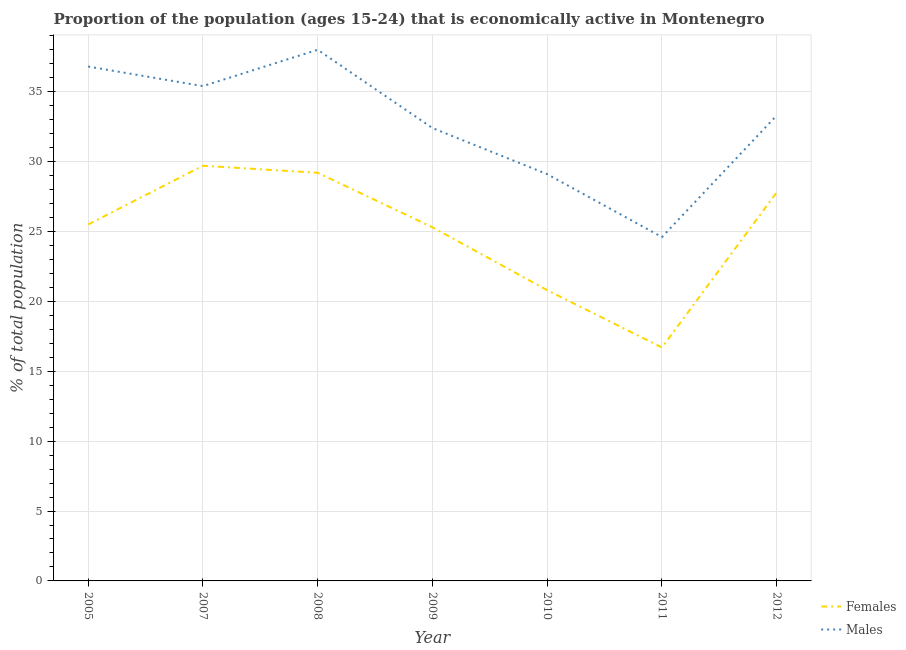How many different coloured lines are there?
Your response must be concise. 2. What is the percentage of economically active male population in 2010?
Ensure brevity in your answer.  29.1. Across all years, what is the minimum percentage of economically active male population?
Provide a short and direct response. 24.6. In which year was the percentage of economically active female population minimum?
Provide a succinct answer. 2011. What is the total percentage of economically active female population in the graph?
Your response must be concise. 175. What is the difference between the percentage of economically active male population in 2010 and that in 2012?
Keep it short and to the point. -4.2. What is the difference between the percentage of economically active female population in 2009 and the percentage of economically active male population in 2010?
Make the answer very short. -3.8. In the year 2010, what is the difference between the percentage of economically active female population and percentage of economically active male population?
Give a very brief answer. -8.3. In how many years, is the percentage of economically active male population greater than 14 %?
Give a very brief answer. 7. What is the ratio of the percentage of economically active female population in 2009 to that in 2011?
Make the answer very short. 1.51. Is the percentage of economically active male population in 2005 less than that in 2007?
Make the answer very short. No. Is the difference between the percentage of economically active female population in 2005 and 2008 greater than the difference between the percentage of economically active male population in 2005 and 2008?
Your answer should be very brief. No. What is the difference between the highest and the second highest percentage of economically active female population?
Make the answer very short. 0.5. What is the difference between the highest and the lowest percentage of economically active female population?
Provide a succinct answer. 13. In how many years, is the percentage of economically active female population greater than the average percentage of economically active female population taken over all years?
Keep it short and to the point. 5. How many years are there in the graph?
Offer a terse response. 7. Does the graph contain any zero values?
Make the answer very short. No. Does the graph contain grids?
Ensure brevity in your answer.  Yes. Where does the legend appear in the graph?
Ensure brevity in your answer.  Bottom right. What is the title of the graph?
Make the answer very short. Proportion of the population (ages 15-24) that is economically active in Montenegro. Does "Young" appear as one of the legend labels in the graph?
Keep it short and to the point. No. What is the label or title of the Y-axis?
Make the answer very short. % of total population. What is the % of total population in Females in 2005?
Provide a succinct answer. 25.5. What is the % of total population of Males in 2005?
Make the answer very short. 36.8. What is the % of total population of Females in 2007?
Ensure brevity in your answer.  29.7. What is the % of total population of Males in 2007?
Provide a short and direct response. 35.4. What is the % of total population in Females in 2008?
Make the answer very short. 29.2. What is the % of total population of Males in 2008?
Offer a very short reply. 38. What is the % of total population of Females in 2009?
Your answer should be compact. 25.3. What is the % of total population in Males in 2009?
Make the answer very short. 32.4. What is the % of total population of Females in 2010?
Offer a terse response. 20.8. What is the % of total population in Males in 2010?
Ensure brevity in your answer.  29.1. What is the % of total population of Females in 2011?
Provide a succinct answer. 16.7. What is the % of total population of Males in 2011?
Offer a very short reply. 24.6. What is the % of total population of Females in 2012?
Offer a very short reply. 27.8. What is the % of total population of Males in 2012?
Ensure brevity in your answer.  33.3. Across all years, what is the maximum % of total population in Females?
Provide a short and direct response. 29.7. Across all years, what is the maximum % of total population in Males?
Provide a succinct answer. 38. Across all years, what is the minimum % of total population in Females?
Ensure brevity in your answer.  16.7. Across all years, what is the minimum % of total population of Males?
Your answer should be compact. 24.6. What is the total % of total population in Females in the graph?
Provide a succinct answer. 175. What is the total % of total population in Males in the graph?
Provide a succinct answer. 229.6. What is the difference between the % of total population in Males in 2005 and that in 2007?
Offer a very short reply. 1.4. What is the difference between the % of total population in Males in 2005 and that in 2008?
Provide a succinct answer. -1.2. What is the difference between the % of total population in Females in 2005 and that in 2010?
Make the answer very short. 4.7. What is the difference between the % of total population in Males in 2005 and that in 2010?
Your answer should be very brief. 7.7. What is the difference between the % of total population in Females in 2005 and that in 2011?
Keep it short and to the point. 8.8. What is the difference between the % of total population of Males in 2005 and that in 2012?
Your response must be concise. 3.5. What is the difference between the % of total population in Males in 2007 and that in 2008?
Offer a very short reply. -2.6. What is the difference between the % of total population in Males in 2007 and that in 2009?
Keep it short and to the point. 3. What is the difference between the % of total population in Males in 2007 and that in 2010?
Give a very brief answer. 6.3. What is the difference between the % of total population in Females in 2007 and that in 2011?
Your answer should be very brief. 13. What is the difference between the % of total population of Males in 2007 and that in 2011?
Provide a short and direct response. 10.8. What is the difference between the % of total population in Females in 2007 and that in 2012?
Offer a terse response. 1.9. What is the difference between the % of total population of Males in 2007 and that in 2012?
Offer a terse response. 2.1. What is the difference between the % of total population of Females in 2008 and that in 2009?
Ensure brevity in your answer.  3.9. What is the difference between the % of total population in Males in 2008 and that in 2009?
Your answer should be compact. 5.6. What is the difference between the % of total population of Females in 2008 and that in 2010?
Give a very brief answer. 8.4. What is the difference between the % of total population in Females in 2008 and that in 2011?
Give a very brief answer. 12.5. What is the difference between the % of total population in Males in 2008 and that in 2011?
Your response must be concise. 13.4. What is the difference between the % of total population of Females in 2009 and that in 2011?
Keep it short and to the point. 8.6. What is the difference between the % of total population of Females in 2009 and that in 2012?
Offer a terse response. -2.5. What is the difference between the % of total population of Females in 2010 and that in 2011?
Keep it short and to the point. 4.1. What is the difference between the % of total population in Males in 2010 and that in 2012?
Give a very brief answer. -4.2. What is the difference between the % of total population of Females in 2011 and that in 2012?
Ensure brevity in your answer.  -11.1. What is the difference between the % of total population of Males in 2011 and that in 2012?
Ensure brevity in your answer.  -8.7. What is the difference between the % of total population of Females in 2005 and the % of total population of Males in 2010?
Your answer should be compact. -3.6. What is the difference between the % of total population in Females in 2005 and the % of total population in Males in 2012?
Keep it short and to the point. -7.8. What is the difference between the % of total population in Females in 2007 and the % of total population in Males in 2008?
Offer a very short reply. -8.3. What is the difference between the % of total population in Females in 2007 and the % of total population in Males in 2009?
Keep it short and to the point. -2.7. What is the difference between the % of total population in Females in 2007 and the % of total population in Males in 2010?
Provide a succinct answer. 0.6. What is the difference between the % of total population of Females in 2007 and the % of total population of Males in 2011?
Ensure brevity in your answer.  5.1. What is the difference between the % of total population of Females in 2007 and the % of total population of Males in 2012?
Ensure brevity in your answer.  -3.6. What is the difference between the % of total population of Females in 2008 and the % of total population of Males in 2009?
Give a very brief answer. -3.2. What is the difference between the % of total population of Females in 2008 and the % of total population of Males in 2010?
Your answer should be very brief. 0.1. What is the difference between the % of total population in Females in 2009 and the % of total population in Males in 2011?
Provide a short and direct response. 0.7. What is the difference between the % of total population of Females in 2009 and the % of total population of Males in 2012?
Make the answer very short. -8. What is the difference between the % of total population in Females in 2010 and the % of total population in Males in 2012?
Offer a terse response. -12.5. What is the difference between the % of total population of Females in 2011 and the % of total population of Males in 2012?
Make the answer very short. -16.6. What is the average % of total population in Females per year?
Make the answer very short. 25. What is the average % of total population in Males per year?
Make the answer very short. 32.8. In the year 2005, what is the difference between the % of total population of Females and % of total population of Males?
Provide a succinct answer. -11.3. In the year 2008, what is the difference between the % of total population in Females and % of total population in Males?
Make the answer very short. -8.8. In the year 2009, what is the difference between the % of total population in Females and % of total population in Males?
Your response must be concise. -7.1. In the year 2010, what is the difference between the % of total population of Females and % of total population of Males?
Your answer should be compact. -8.3. In the year 2012, what is the difference between the % of total population in Females and % of total population in Males?
Make the answer very short. -5.5. What is the ratio of the % of total population in Females in 2005 to that in 2007?
Your response must be concise. 0.86. What is the ratio of the % of total population in Males in 2005 to that in 2007?
Your answer should be compact. 1.04. What is the ratio of the % of total population in Females in 2005 to that in 2008?
Give a very brief answer. 0.87. What is the ratio of the % of total population of Males in 2005 to that in 2008?
Provide a succinct answer. 0.97. What is the ratio of the % of total population in Females in 2005 to that in 2009?
Ensure brevity in your answer.  1.01. What is the ratio of the % of total population of Males in 2005 to that in 2009?
Make the answer very short. 1.14. What is the ratio of the % of total population in Females in 2005 to that in 2010?
Your answer should be very brief. 1.23. What is the ratio of the % of total population in Males in 2005 to that in 2010?
Provide a succinct answer. 1.26. What is the ratio of the % of total population in Females in 2005 to that in 2011?
Your answer should be compact. 1.53. What is the ratio of the % of total population of Males in 2005 to that in 2011?
Your answer should be very brief. 1.5. What is the ratio of the % of total population in Females in 2005 to that in 2012?
Offer a terse response. 0.92. What is the ratio of the % of total population in Males in 2005 to that in 2012?
Your response must be concise. 1.11. What is the ratio of the % of total population in Females in 2007 to that in 2008?
Offer a terse response. 1.02. What is the ratio of the % of total population of Males in 2007 to that in 2008?
Your answer should be very brief. 0.93. What is the ratio of the % of total population of Females in 2007 to that in 2009?
Make the answer very short. 1.17. What is the ratio of the % of total population in Males in 2007 to that in 2009?
Your response must be concise. 1.09. What is the ratio of the % of total population in Females in 2007 to that in 2010?
Give a very brief answer. 1.43. What is the ratio of the % of total population of Males in 2007 to that in 2010?
Your answer should be very brief. 1.22. What is the ratio of the % of total population of Females in 2007 to that in 2011?
Provide a succinct answer. 1.78. What is the ratio of the % of total population of Males in 2007 to that in 2011?
Keep it short and to the point. 1.44. What is the ratio of the % of total population in Females in 2007 to that in 2012?
Your response must be concise. 1.07. What is the ratio of the % of total population of Males in 2007 to that in 2012?
Ensure brevity in your answer.  1.06. What is the ratio of the % of total population of Females in 2008 to that in 2009?
Keep it short and to the point. 1.15. What is the ratio of the % of total population in Males in 2008 to that in 2009?
Provide a short and direct response. 1.17. What is the ratio of the % of total population of Females in 2008 to that in 2010?
Offer a terse response. 1.4. What is the ratio of the % of total population of Males in 2008 to that in 2010?
Offer a terse response. 1.31. What is the ratio of the % of total population in Females in 2008 to that in 2011?
Your response must be concise. 1.75. What is the ratio of the % of total population of Males in 2008 to that in 2011?
Make the answer very short. 1.54. What is the ratio of the % of total population of Females in 2008 to that in 2012?
Your response must be concise. 1.05. What is the ratio of the % of total population of Males in 2008 to that in 2012?
Make the answer very short. 1.14. What is the ratio of the % of total population of Females in 2009 to that in 2010?
Your response must be concise. 1.22. What is the ratio of the % of total population in Males in 2009 to that in 2010?
Offer a very short reply. 1.11. What is the ratio of the % of total population in Females in 2009 to that in 2011?
Offer a very short reply. 1.51. What is the ratio of the % of total population in Males in 2009 to that in 2011?
Offer a very short reply. 1.32. What is the ratio of the % of total population of Females in 2009 to that in 2012?
Offer a very short reply. 0.91. What is the ratio of the % of total population in Males in 2009 to that in 2012?
Your response must be concise. 0.97. What is the ratio of the % of total population of Females in 2010 to that in 2011?
Provide a succinct answer. 1.25. What is the ratio of the % of total population in Males in 2010 to that in 2011?
Your answer should be very brief. 1.18. What is the ratio of the % of total population of Females in 2010 to that in 2012?
Your answer should be compact. 0.75. What is the ratio of the % of total population of Males in 2010 to that in 2012?
Your answer should be very brief. 0.87. What is the ratio of the % of total population in Females in 2011 to that in 2012?
Keep it short and to the point. 0.6. What is the ratio of the % of total population in Males in 2011 to that in 2012?
Your response must be concise. 0.74. What is the difference between the highest and the lowest % of total population of Males?
Offer a terse response. 13.4. 